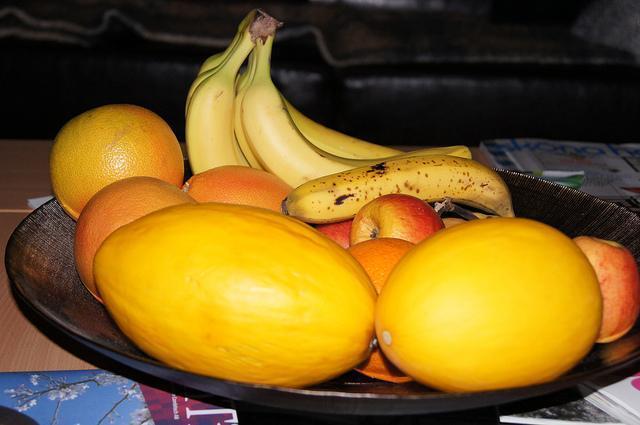Does the description: "The couch is behind the bowl." accurately reflect the image?
Answer yes or no. Yes. 